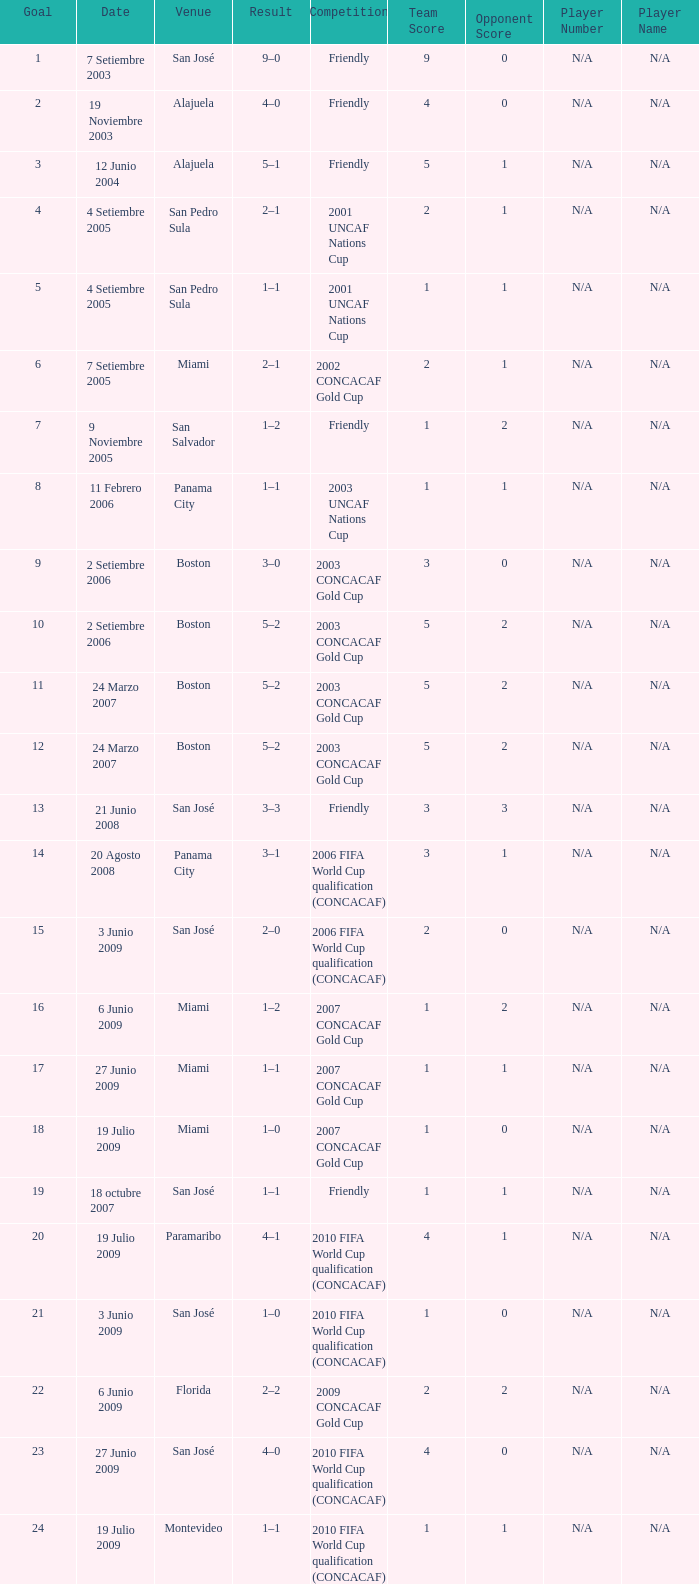At the venue of panama city, on 11 Febrero 2006, how many goals were scored? 1.0. Help me parse the entirety of this table. {'header': ['Goal', 'Date', 'Venue', 'Result', 'Competition', 'Team Score', 'Opponent Score', 'Player Number', 'Player Name'], 'rows': [['1', '7 Setiembre 2003', 'San José', '9–0', 'Friendly', '9', '0', 'N/A', 'N/A'], ['2', '19 Noviembre 2003', 'Alajuela', '4–0', 'Friendly', '4', '0', 'N/A', 'N/A'], ['3', '12 Junio 2004', 'Alajuela', '5–1', 'Friendly', '5', '1', 'N/A', 'N/A'], ['4', '4 Setiembre 2005', 'San Pedro Sula', '2–1', '2001 UNCAF Nations Cup', '2', '1', 'N/A', 'N/A'], ['5', '4 Setiembre 2005', 'San Pedro Sula', '1–1', '2001 UNCAF Nations Cup', '1', '1', 'N/A', 'N/A'], ['6', '7 Setiembre 2005', 'Miami', '2–1', '2002 CONCACAF Gold Cup', '2', '1', 'N/A', 'N/A'], ['7', '9 Noviembre 2005', 'San Salvador', '1–2', 'Friendly', '1', '2', 'N/A', 'N/A'], ['8', '11 Febrero 2006', 'Panama City', '1–1', '2003 UNCAF Nations Cup', '1', '1', 'N/A', 'N/A'], ['9', '2 Setiembre 2006', 'Boston', '3–0', '2003 CONCACAF Gold Cup', '3', '0', 'N/A', 'N/A'], ['10', '2 Setiembre 2006', 'Boston', '5–2', '2003 CONCACAF Gold Cup', '5', '2', 'N/A', 'N/A'], ['11', '24 Marzo 2007', 'Boston', '5–2', '2003 CONCACAF Gold Cup', '5', '2', 'N/A', 'N/A'], ['12', '24 Marzo 2007', 'Boston', '5–2', '2003 CONCACAF Gold Cup', '5', '2', 'N/A', 'N/A'], ['13', '21 Junio 2008', 'San José', '3–3', 'Friendly', '3', '3', 'N/A', 'N/A'], ['14', '20 Agosto 2008', 'Panama City', '3–1', '2006 FIFA World Cup qualification (CONCACAF)', '3', '1', 'N/A', 'N/A'], ['15', '3 Junio 2009', 'San José', '2–0', '2006 FIFA World Cup qualification (CONCACAF)', '2', '0', 'N/A', 'N/A'], ['16', '6 Junio 2009', 'Miami', '1–2', '2007 CONCACAF Gold Cup', '1', '2', 'N/A', 'N/A'], ['17', '27 Junio 2009', 'Miami', '1–1', '2007 CONCACAF Gold Cup', '1', '1', 'N/A', 'N/A'], ['18', '19 Julio 2009', 'Miami', '1–0', '2007 CONCACAF Gold Cup', '1', '0', 'N/A', 'N/A'], ['19', '18 octubre 2007', 'San José', '1–1', 'Friendly', '1', '1', 'N/A', 'N/A'], ['20', '19 Julio 2009', 'Paramaribo', '4–1', '2010 FIFA World Cup qualification (CONCACAF)', '4', '1', 'N/A', 'N/A'], ['21', '3 Junio 2009', 'San José', '1–0', '2010 FIFA World Cup qualification (CONCACAF)', '1', '0', 'N/A', 'N/A'], ['22', '6 Junio 2009', 'Florida', '2–2', '2009 CONCACAF Gold Cup', '2', '2', 'N/A', 'N/A'], ['23', '27 Junio 2009', 'San José', '4–0', '2010 FIFA World Cup qualification (CONCACAF)', '4', '0', 'N/A', 'N/A'], ['24', '19 Julio 2009', 'Montevideo', '1–1', '2010 FIFA World Cup qualification (CONCACAF)', '1', '1', 'N/A', 'N/A']]} 